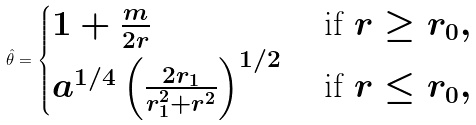Convert formula to latex. <formula><loc_0><loc_0><loc_500><loc_500>\hat { \theta } = \begin{cases} 1 + \frac { m } { 2 r } & \text { if } r \geq r _ { 0 } , \\ a ^ { 1 / 4 } \left ( \frac { 2 r _ { 1 } } { r _ { 1 } ^ { 2 } + r ^ { 2 } } \right ) ^ { 1 / 2 } & \text { if } r \leq r _ { 0 } , \end{cases}</formula> 